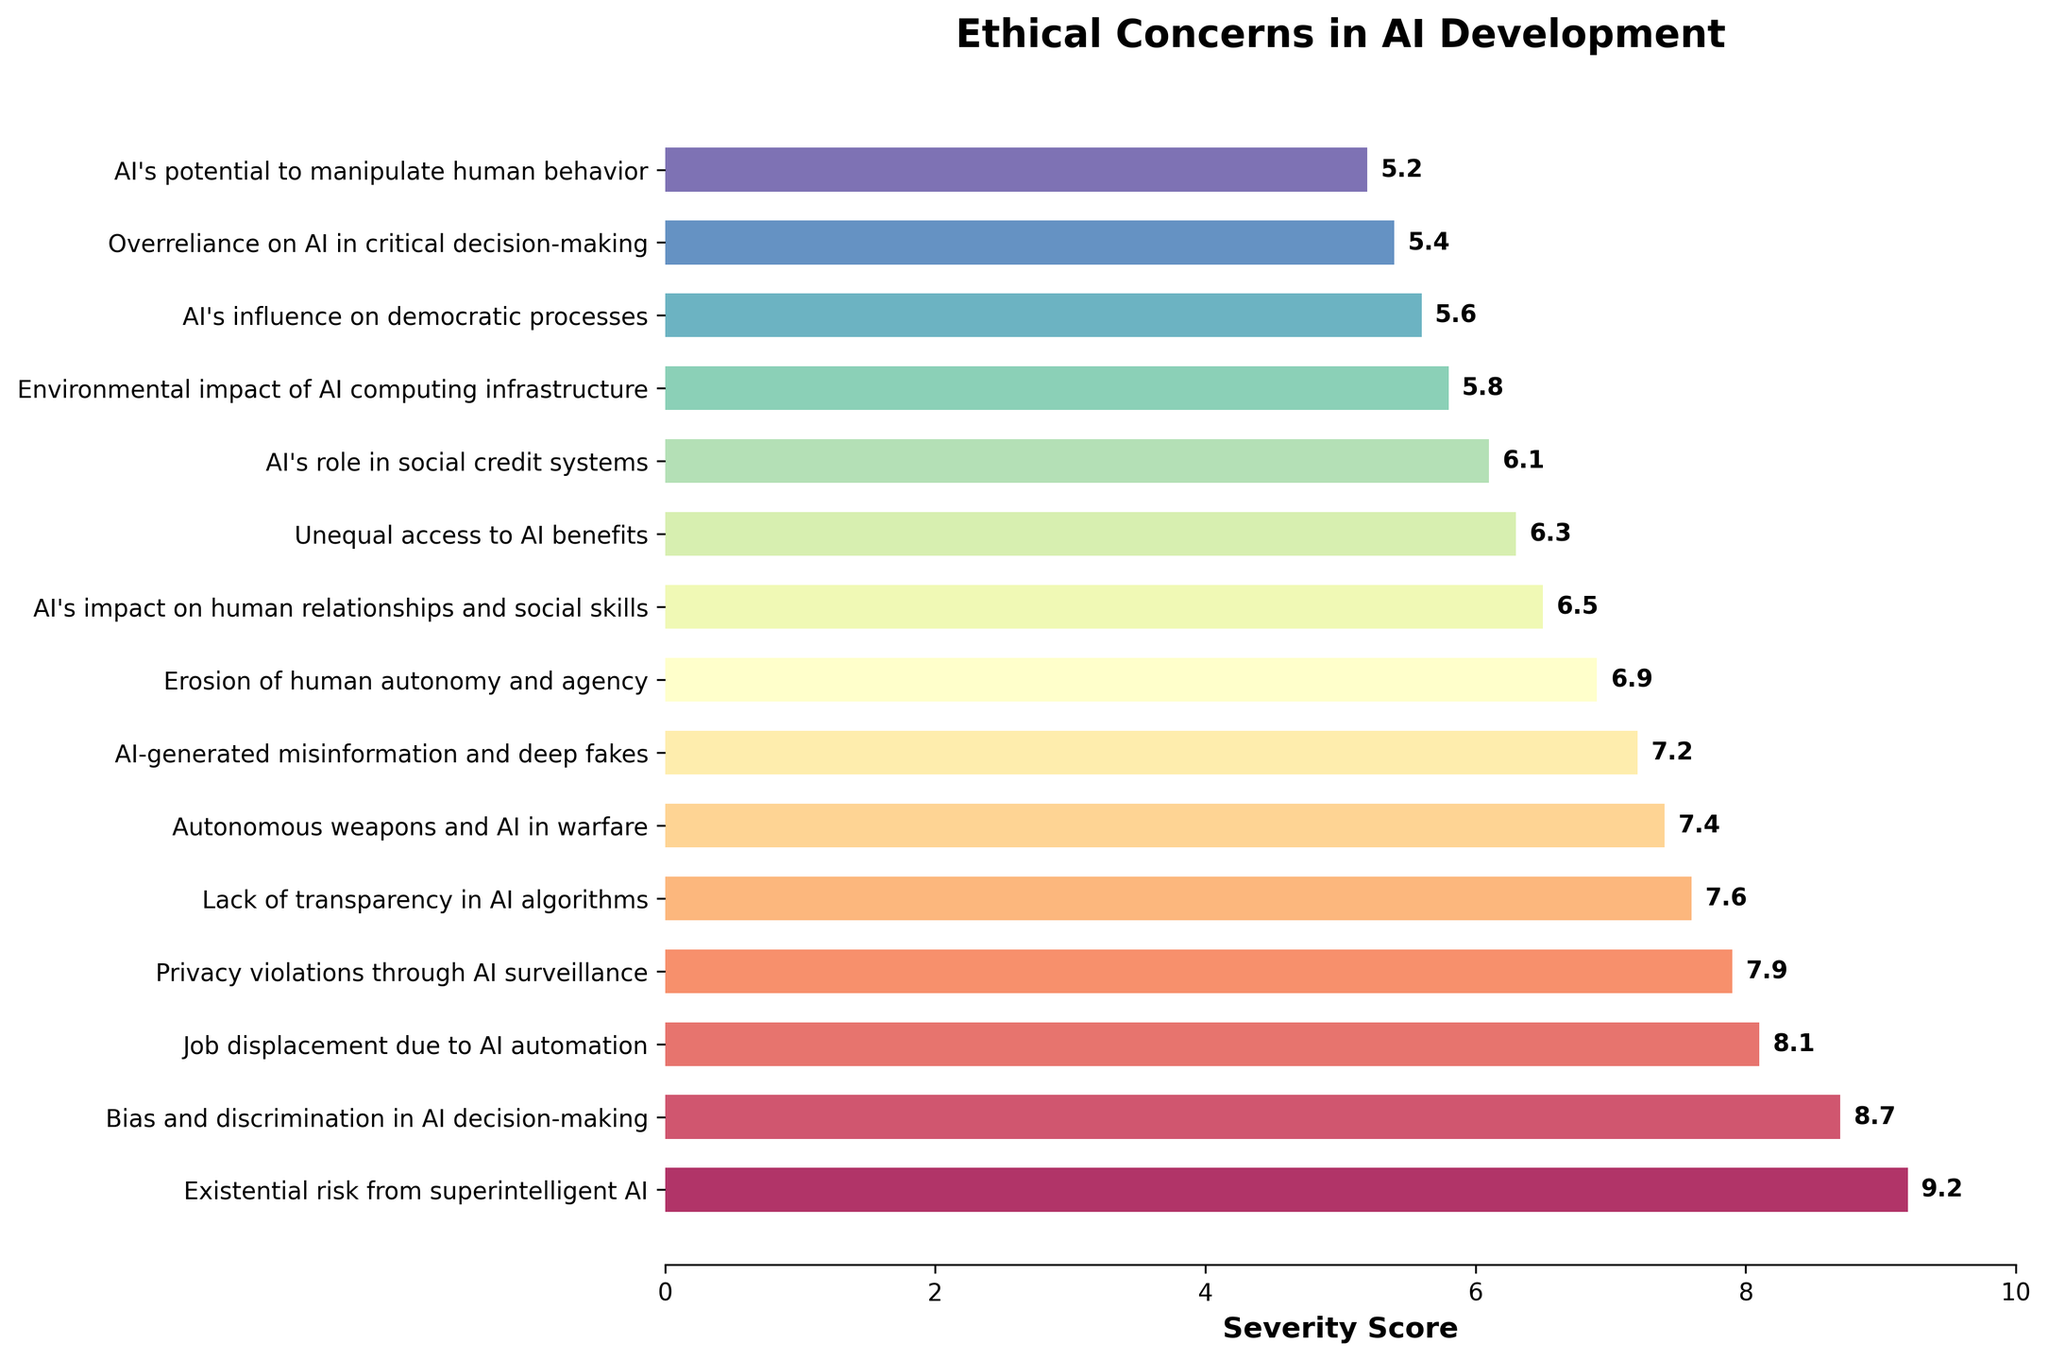What is the most severe ethical concern regarding AI development? The figure shows a bar chart with various ethical concerns ranked by severity. The highest bar corresponds to "Existential risk from superintelligent AI" with a score of 9.2, indicating it is the most severe concern.
Answer: Existential risk from superintelligent AI Which ethical concern has the lowest severity score? By observing the figure, the shortest bar at the bottom of the chart represents "AI's potential to manipulate human behavior" with a severity score of 5.2, indicating it has the lowest score.
Answer: AI's potential to manipulate human behavior How much greater is the severity score of "Bias and discrimination in AI decision-making" compared to "AI-generated misinformation and deep fakes"? "Bias and discrimination in AI decision-making" has a severity score of 8.7, while "AI-generated misinformation and deep fakes" has 7.2. Subtract the two scores: 8.7 - 7.2 = 1.5
Answer: 1.5 Which concerns have a severity score higher than 7 but lower than 9? Observing the figure, the concerns with severity scores higher than 7 and lower than 9 are "Bias and discrimination in AI decision-making" (8.7), "Job displacement due to AI automation" (8.1), and "Privacy violations through AI surveillance" (7.9).
Answer: Bias and discrimination in AI decision-making; Job displacement due to AI automation; Privacy violations through AI surveillance What is the combined severity score of the top three ethical concerns? The top three concerns are "Existential risk from superintelligent AI" (9.2), "Bias and discrimination in AI decision-making" (8.7), and "Job displacement due to AI automation" (8.1). Adding these scores gives: 9.2 + 8.7 + 8.1 = 26.0
Answer: 26.0 Compare the severity scores of "Autonomous weapons and AI in warfare" and "Environmental impact of AI computing infrastructure". Which is higher and by how much? "Autonomous weapons and AI in warfare" has a severity score of 7.4, while "Environmental impact of AI computing infrastructure" has 5.8. The difference is 7.4 - 5.8 = 1.6, with "Autonomous weapons and AI in warfare" being higher.
Answer: Autonomous weapons and AI in warfare; 1.6 